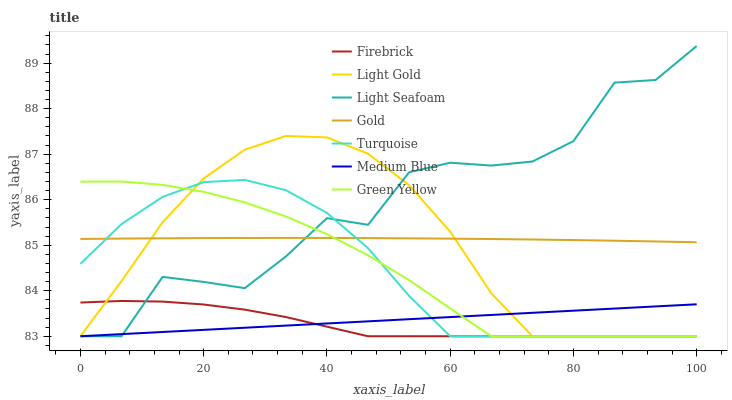Does Firebrick have the minimum area under the curve?
Answer yes or no. Yes. Does Light Seafoam have the maximum area under the curve?
Answer yes or no. Yes. Does Green Yellow have the minimum area under the curve?
Answer yes or no. No. Does Green Yellow have the maximum area under the curve?
Answer yes or no. No. Is Medium Blue the smoothest?
Answer yes or no. Yes. Is Light Seafoam the roughest?
Answer yes or no. Yes. Is Green Yellow the smoothest?
Answer yes or no. No. Is Green Yellow the roughest?
Answer yes or no. No. Does Turquoise have the lowest value?
Answer yes or no. Yes. Does Gold have the lowest value?
Answer yes or no. No. Does Light Seafoam have the highest value?
Answer yes or no. Yes. Does Green Yellow have the highest value?
Answer yes or no. No. Is Firebrick less than Gold?
Answer yes or no. Yes. Is Gold greater than Firebrick?
Answer yes or no. Yes. Does Light Seafoam intersect Medium Blue?
Answer yes or no. Yes. Is Light Seafoam less than Medium Blue?
Answer yes or no. No. Is Light Seafoam greater than Medium Blue?
Answer yes or no. No. Does Firebrick intersect Gold?
Answer yes or no. No. 